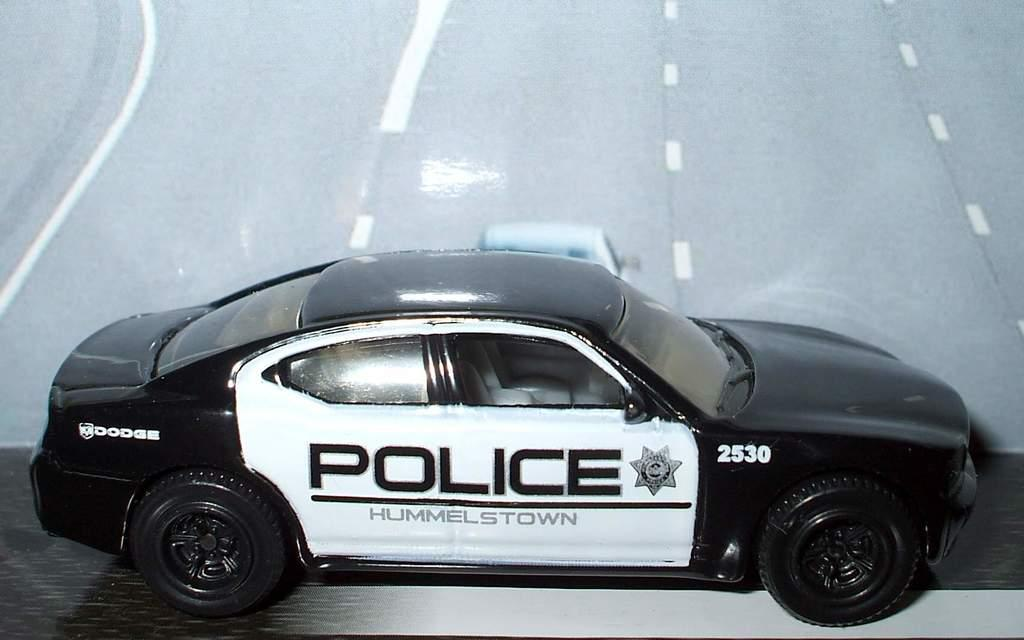What type of toy is in the image? There is a toy police car in the image. Where is the toy located? The toy police car is on a table. What type of impulse can be seen affecting the toy police car in the image? There is no impulse affecting the toy police car in the image; it is stationary on the table. Can you see a kitten playing with the toy police car in the image? There is no kitten present in the image. 